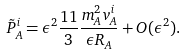Convert formula to latex. <formula><loc_0><loc_0><loc_500><loc_500>\tilde { P } _ { A } ^ { i } = \epsilon ^ { 2 } \frac { 1 1 } { 3 } \frac { m _ { A } ^ { 2 } v _ { A } ^ { i } } { \epsilon R _ { A } } + O ( \epsilon ^ { 2 } ) .</formula> 